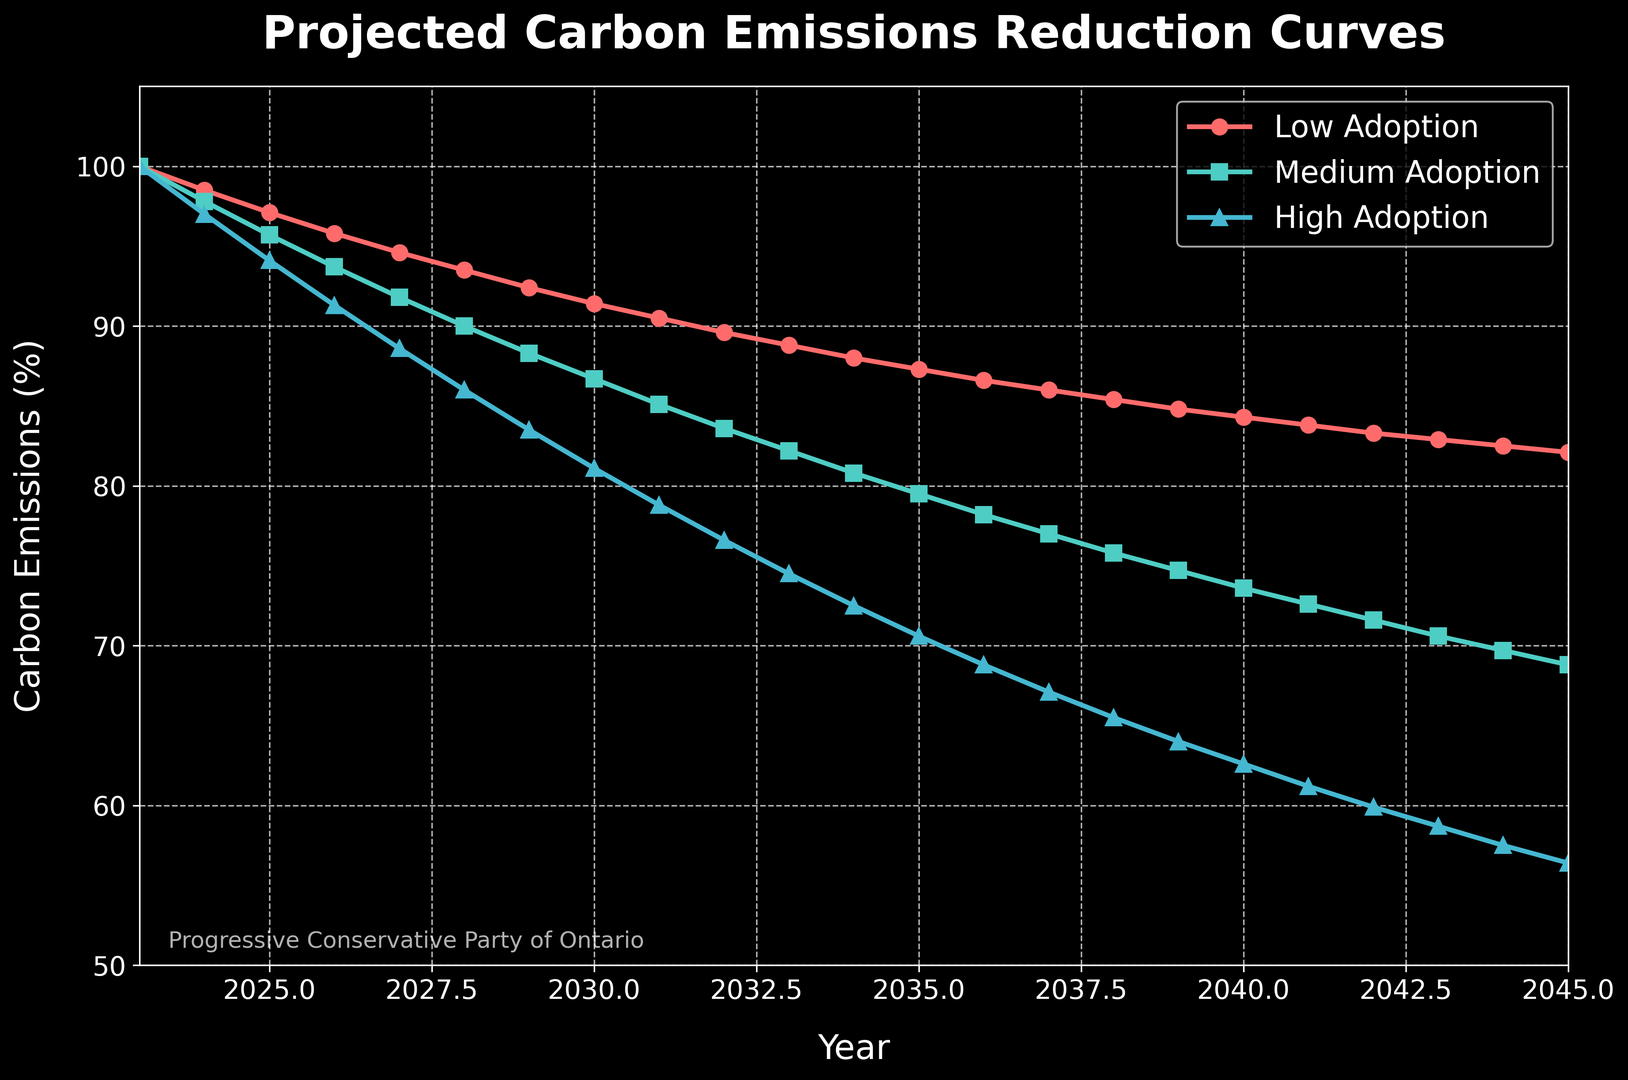What is the projected difference in carbon emissions reduction between High Adoption and Low Adoption in 2025? Look at the values for 2025, which are 97.1 for Low Adoption and 94.1 for High Adoption. The difference is 97.1 - 94.1 = 3.0
Answer: 3.0 In which year do the projected carbon emissions for High Adoption drop below 80%? Examine the High Adoption curve and find the year where the value first goes below 80%. In 2031, High Adoption is 78.8%
Answer: 2031 How much greater are the emissions in the Low Adoption scenario compared to the Medium Adoption scenario in 2045? Look at the values for 2045, which are 82.1 for Low Adoption and 68.8 for Medium Adoption. The difference is 82.1 - 68.8 = 13.3
Answer: 13.3 What color represents the Medium Adoption scenario? By referring to the plot legend, the Medium Adoption scenario is represented by the green color
Answer: green By how much do emissions decrease in the High Adoption scenario between 2029 and 2030? Look at the values for High Adoption in 2029 and 2030, which are 83.5% and 81.1%, respectively. The decrease is 83.5 - 81.1 = 2.4
Answer: 2.4 At what rate do emissions reduce from the year 2024 to 2025 in the Low Adoption scenario? Look at the values for Low Adoption in 2024 and 2025, which are 98.5 and 97.1, respectively. The rate of reduction is (98.5 - 97.1) / (2025 - 2024) = 1.4 per year
Answer: 1.4 per year What year sees Medium Adoption emissions drop below 85%? Examine the Medium Adoption curve to find the year where the value first goes below 85%. In 2029, Medium Adoption is 84.7%
Answer: 2029 What is the average projected carbon emissions for Medium Adoption from 2023 to 2025? Sum the Medium Adoption values for 2023, 2024, and 2025, which are 100 + 97.8 + 95.7 = 293.5. The average is 293.5 / 3 = 97.83
Answer: 97.83 Which adoption scenario has the steepest reduction in emissions by 2030? Compare the reduction from 2023 to 2030 for each scenario. High Adoption reduces from 100 to 81.1, Medium Adoption from 100 to 86.7, and Low Adoption from 100 to 91.4. The steepest reduction is in High Adoption
Answer: High Adoption 